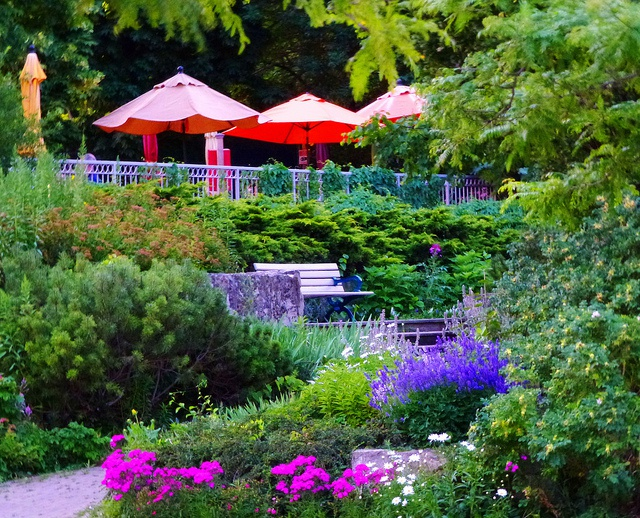Describe the objects in this image and their specific colors. I can see umbrella in black, pink, red, and brown tones, umbrella in black, red, lavender, and brown tones, umbrella in black, orange, olive, and darkgreen tones, bench in black, lavender, violet, and purple tones, and umbrella in black, pink, lightpink, and darkgray tones in this image. 